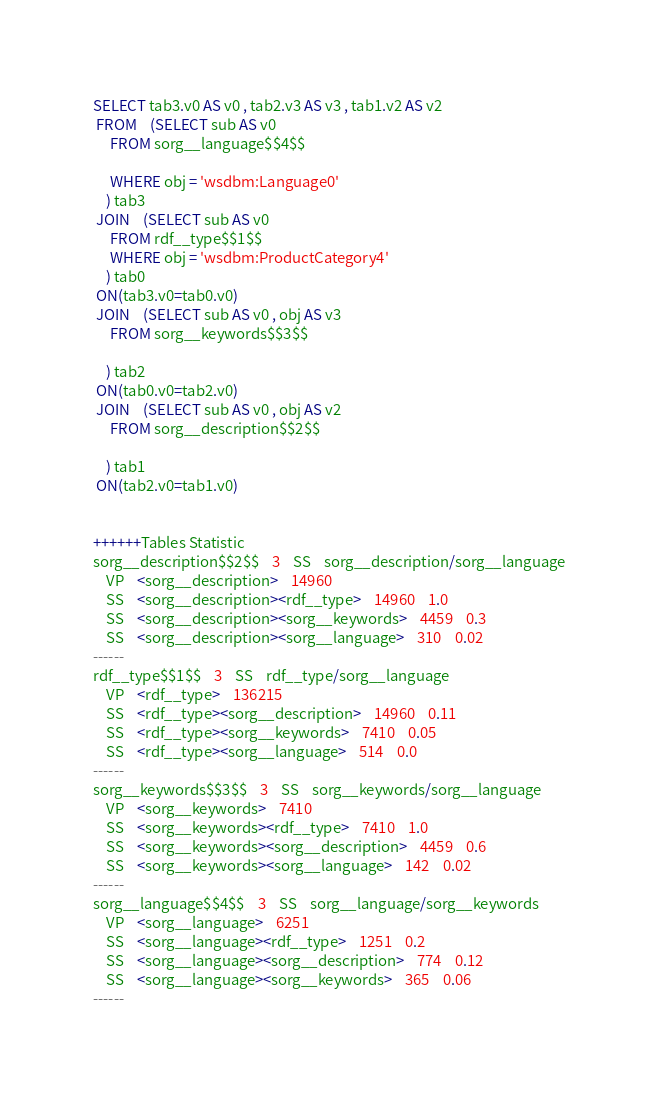Convert code to text. <code><loc_0><loc_0><loc_500><loc_500><_SQL_>SELECT tab3.v0 AS v0 , tab2.v3 AS v3 , tab1.v2 AS v2 
 FROM    (SELECT sub AS v0 
	 FROM sorg__language$$4$$
	 
	 WHERE obj = 'wsdbm:Language0'
	) tab3
 JOIN    (SELECT sub AS v0 
	 FROM rdf__type$$1$$ 
	 WHERE obj = 'wsdbm:ProductCategory4'
	) tab0
 ON(tab3.v0=tab0.v0)
 JOIN    (SELECT sub AS v0 , obj AS v3 
	 FROM sorg__keywords$$3$$
	
	) tab2
 ON(tab0.v0=tab2.v0)
 JOIN    (SELECT sub AS v0 , obj AS v2 
	 FROM sorg__description$$2$$
	
	) tab1
 ON(tab2.v0=tab1.v0)


++++++Tables Statistic
sorg__description$$2$$	3	SS	sorg__description/sorg__language
	VP	<sorg__description>	14960
	SS	<sorg__description><rdf__type>	14960	1.0
	SS	<sorg__description><sorg__keywords>	4459	0.3
	SS	<sorg__description><sorg__language>	310	0.02
------
rdf__type$$1$$	3	SS	rdf__type/sorg__language
	VP	<rdf__type>	136215
	SS	<rdf__type><sorg__description>	14960	0.11
	SS	<rdf__type><sorg__keywords>	7410	0.05
	SS	<rdf__type><sorg__language>	514	0.0
------
sorg__keywords$$3$$	3	SS	sorg__keywords/sorg__language
	VP	<sorg__keywords>	7410
	SS	<sorg__keywords><rdf__type>	7410	1.0
	SS	<sorg__keywords><sorg__description>	4459	0.6
	SS	<sorg__keywords><sorg__language>	142	0.02
------
sorg__language$$4$$	3	SS	sorg__language/sorg__keywords
	VP	<sorg__language>	6251
	SS	<sorg__language><rdf__type>	1251	0.2
	SS	<sorg__language><sorg__description>	774	0.12
	SS	<sorg__language><sorg__keywords>	365	0.06
------
</code> 